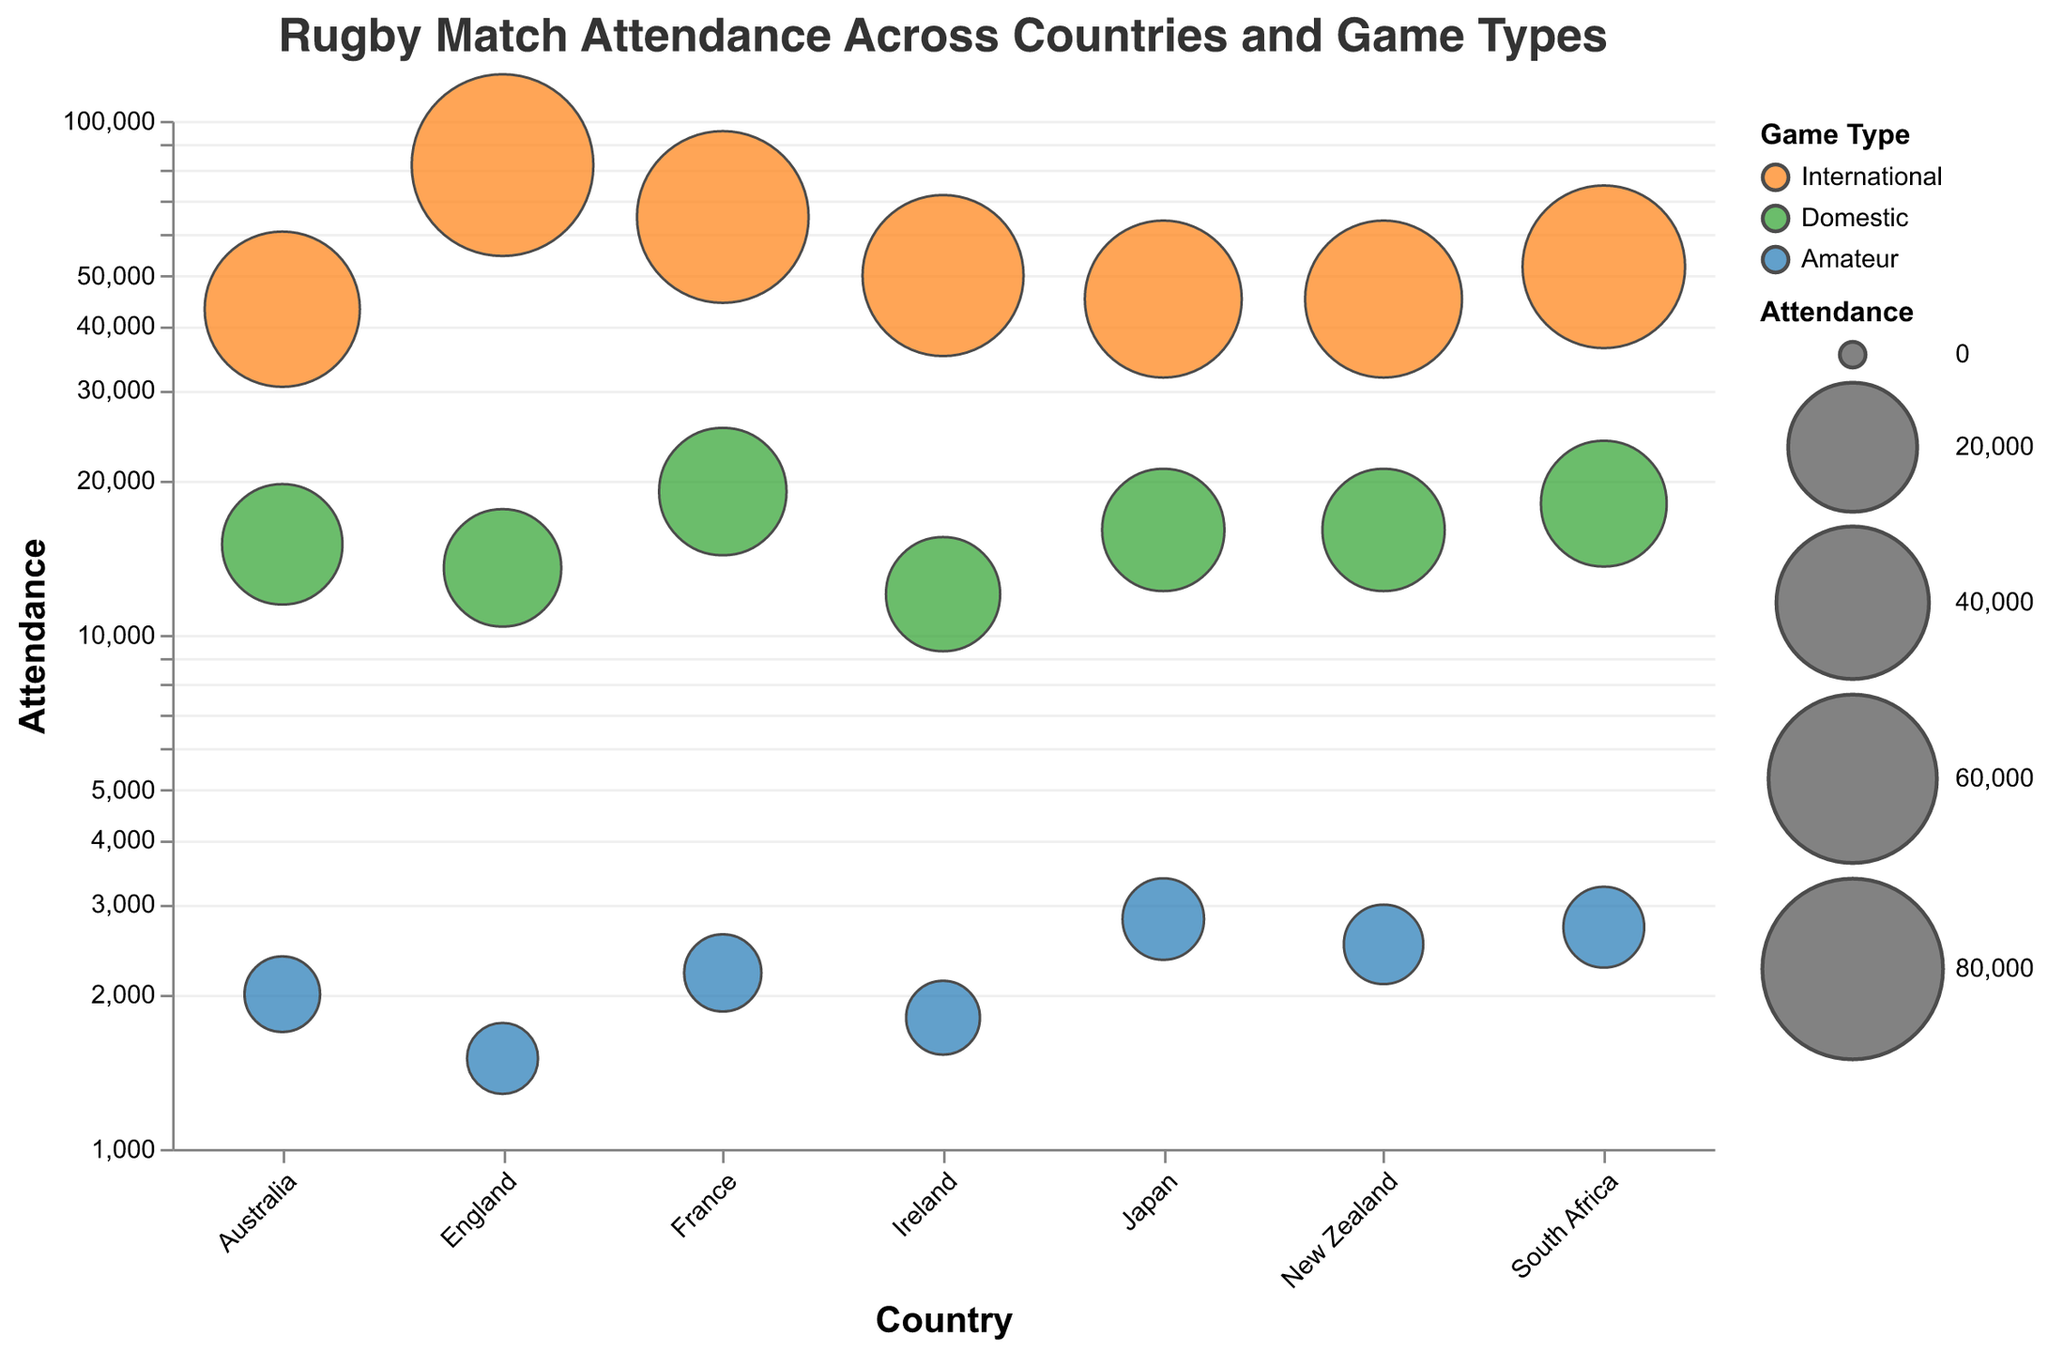what is the title of the figure? The title is typically displayed at the top of the chart. Reading it directly from the provided description, the title is "Rugby Match Attendance Across Countries and Game Types".
Answer: Rugby Match Attendance Across Countries and Game Types How many bubbles represent amateur games? By identifying the unique color assigned to amateur games (blue) in the legend and counting the bubbles of that color, we can determine the number. There are 6 countries listed, each with one amateur game represented, so there are 6 bubbles for amateur games in total.
Answer: 6 Which country has the highest attendance for international games? Using the color-coding for international games (orange) and observing the size of the corresponding bubbles, England has the largest bubble at 82,000 attendees for international games.
Answer: England What is the smallest attendance displayed in the figure? By examining the smallest bubbles, we see the smallest attendance is for England's amateur game with Rosslyn Park and Blackheath, which has an attendance of 1,500.
Answer: 1,500 Compare the attendance of International games in New Zealand and South Africa. Which country has more? By looking at the size and inspecting the tooltip for international game bubbles in New Zealand and South Africa, New Zealand has an attendance of 45,000 whereas South Africa has an attendance of 52,000. South Africa has more.
Answer: South Africa What is the difference in attendance between France's international and domestic games? The international game in France has an attendance of 65,000, and the domestic game has 19,000. The difference is 65,000 - 19,000 = 46,000.
Answer: 46,000 Identify the country with the highest attendance for domestic games. Observing the green color bubbles for domestic games and their sizes, France's domestic game has the highest attendance at 19,000.
Answer: France What is the average attendance for all amateur games? Adding up the attendance figures for all amateur games: 2,500 (New Zealand) + 1,500 (England) + 2,200 (France) + 2,700 (South Africa) + 2,000 (Australia) + 2,800 (Japan) + 1,800 (Ireland) = 15,500. There are 7 data points, so the average is 15,500 / 7 = 2,214.
Answer: 2,214 How does New Zealand's domestic game attendance compare with Australia's? By checking the green color bubbles for domestic games for both countries and verifying from the tooltips, New Zealand has 16,000 attendees, whereas Australia has 15,000. New Zealand has a slightly higher attendance.
Answer: New Zealand Which game type generally has the highest attendance in each country? Observing the size of bubbles and the color coding for game types across various countries, international games (orange bubbles) generally have the highest attendance across all countries listed.
Answer: International 